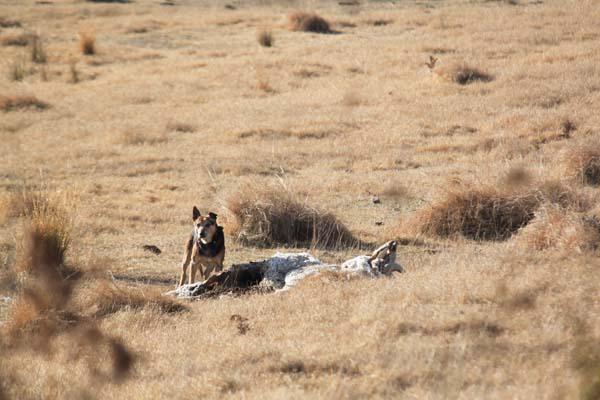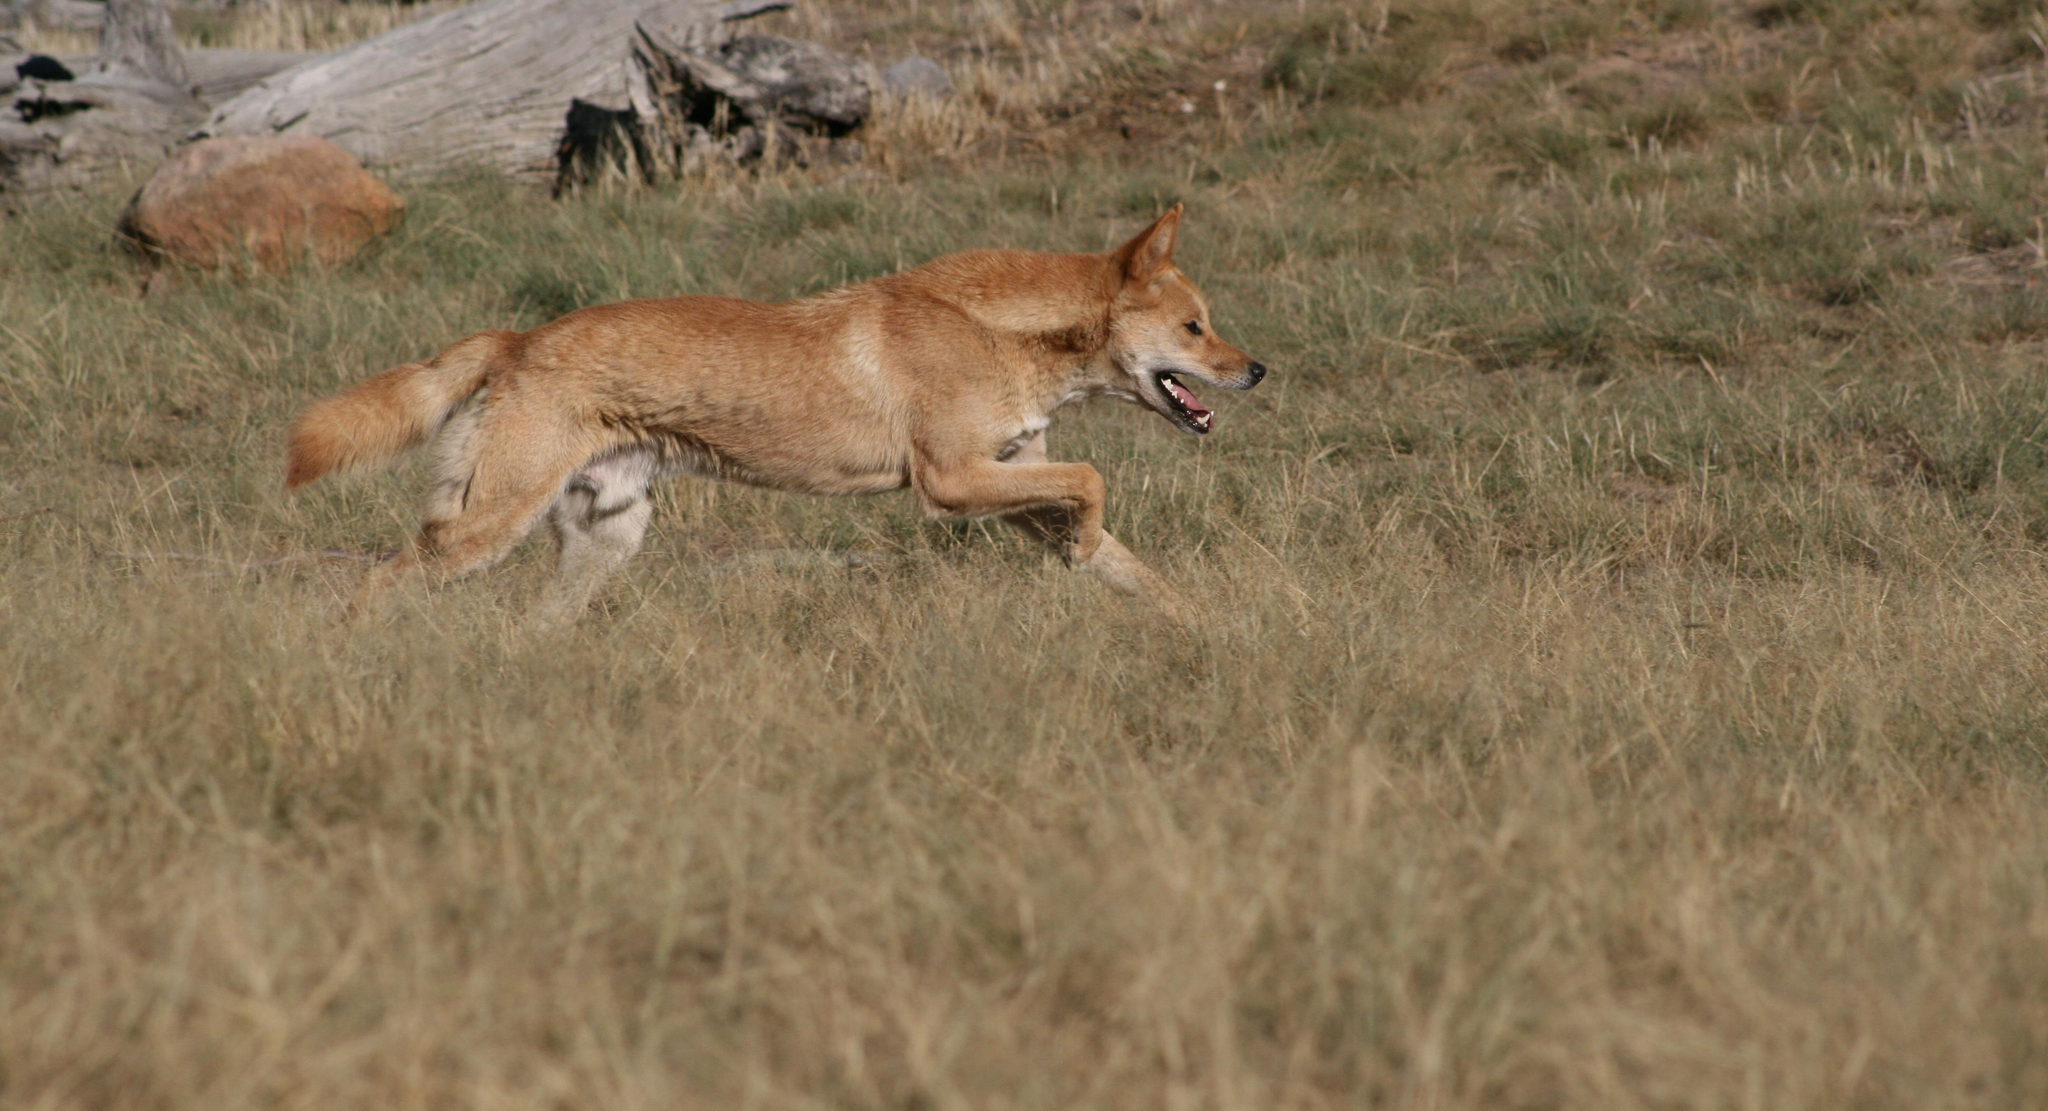The first image is the image on the left, the second image is the image on the right. Analyze the images presented: Is the assertion "An image shows at least one dog standing by a carcass." valid? Answer yes or no. Yes. 